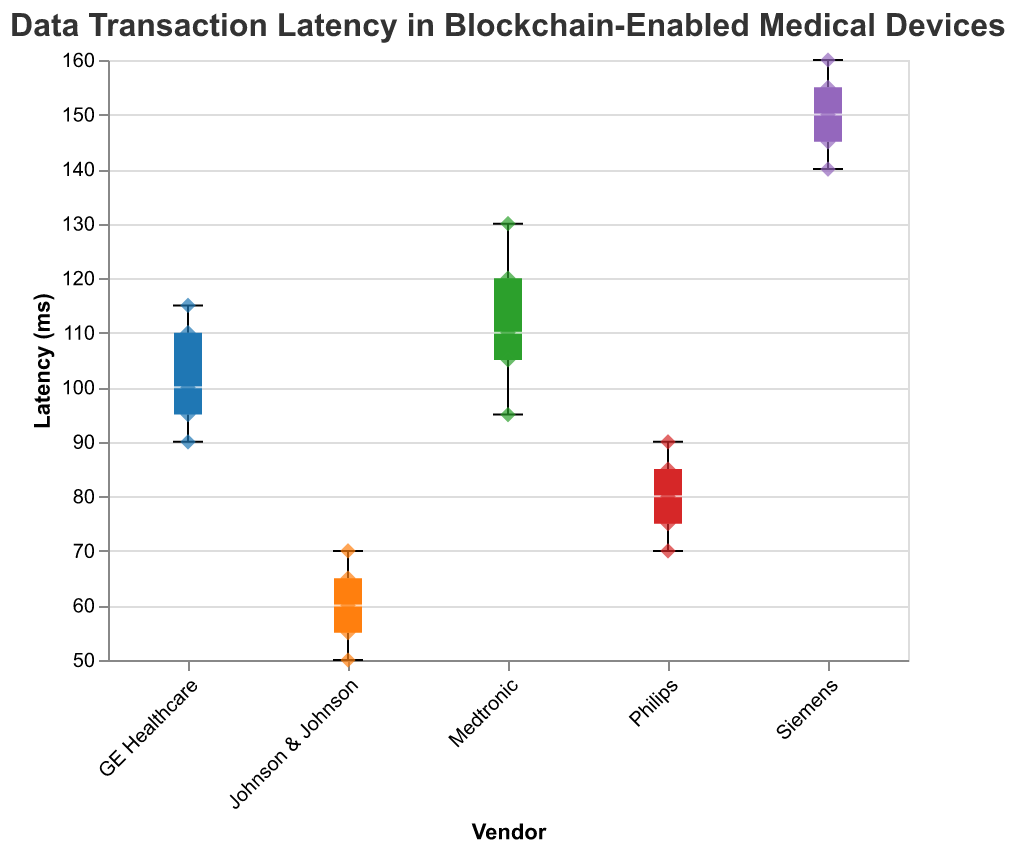What is the title of the figure? The title is written at the top of the figure. It reads "Data Transaction Latency in Blockchain-Enabled Medical Devices".
Answer: Data Transaction Latency in Blockchain-Enabled Medical Devices Which vendor has the lowest median latency? The median latency is shown by the line within each box, and the vendor with the lowest median line is Johnson & Johnson.
Answer: Johnson & Johnson What are the minimum and maximum latencies for Philips? The whiskers of the box plot represent the minimum and maximum values. For Philips, the minimum latency is 70 ms and the maximum latency is 90 ms as indicated by the ends of the whiskers.
Answer: 70 ms, 90 ms How does the latency spread of Siemens compare with that of Medtronic? The box plot for Siemens is taller than that of Medtronic, indicating a larger spread. Siemens also has higher minimum and maximum values compared to Medtronic.
Answer: Larger spread, higher latencies Which vendor showed the most consistency in latency? Consistency can be interpreted as the smallest range from the whiskers of the box plot. Johnson & Johnson shows the most consistency as its box plot is the shortest, indicating the smallest range.
Answer: Johnson & Johnson Which vendor had the highest maximum latency? The maximum latency is represented by the highest whisker on the box plot, which belongs to Siemens.
Answer: Siemens What is the median latency for GE Healthcare? The line inside the box for GE Healthcare indicates the median, which appears to be 100 ms.
Answer: 100 ms How many data points are there for Medtronic? Counting the scatter points within the Medtronic box plot, there are five data points plotted.
Answer: 5 What shapes represent the data points in the figure? The individual data points are represented by diamond shapes scattered around the box plots.
Answer: Diamond shapes Which vendor has the widest interquartile range (IQR)? The IQR is represented by the height of the box. Siemens has the widest interquartile range as its box is the tallest.
Answer: Siemens 